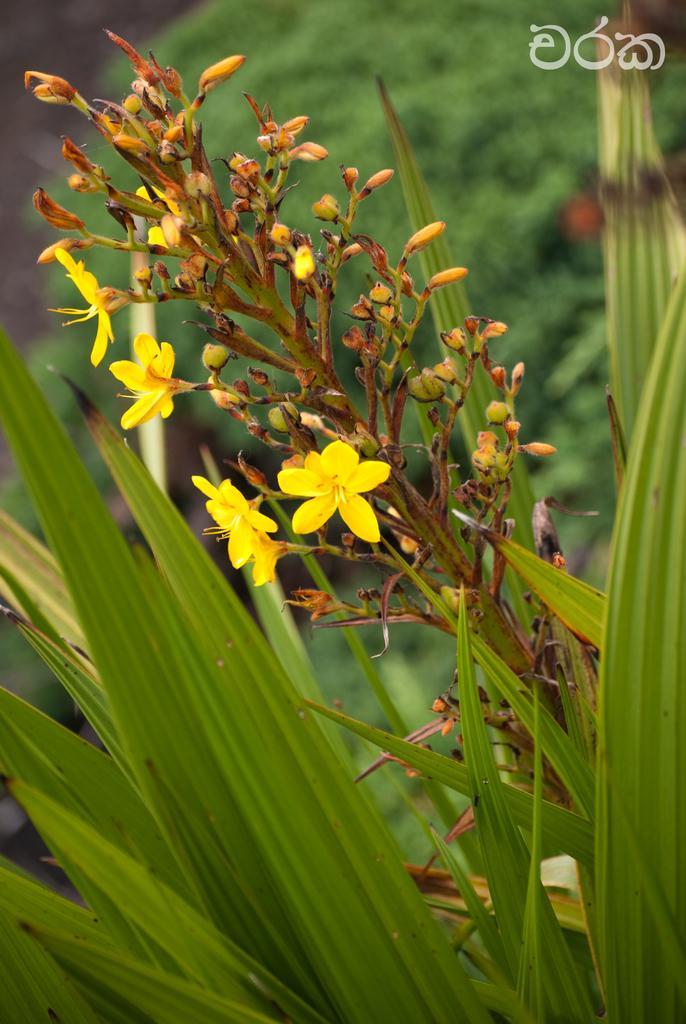How would you summarize this image in a sentence or two? As we can see in the image there are plants, flowers and trees. 